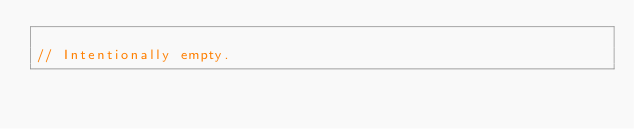<code> <loc_0><loc_0><loc_500><loc_500><_C++_>
// Intentionally empty.
</code> 